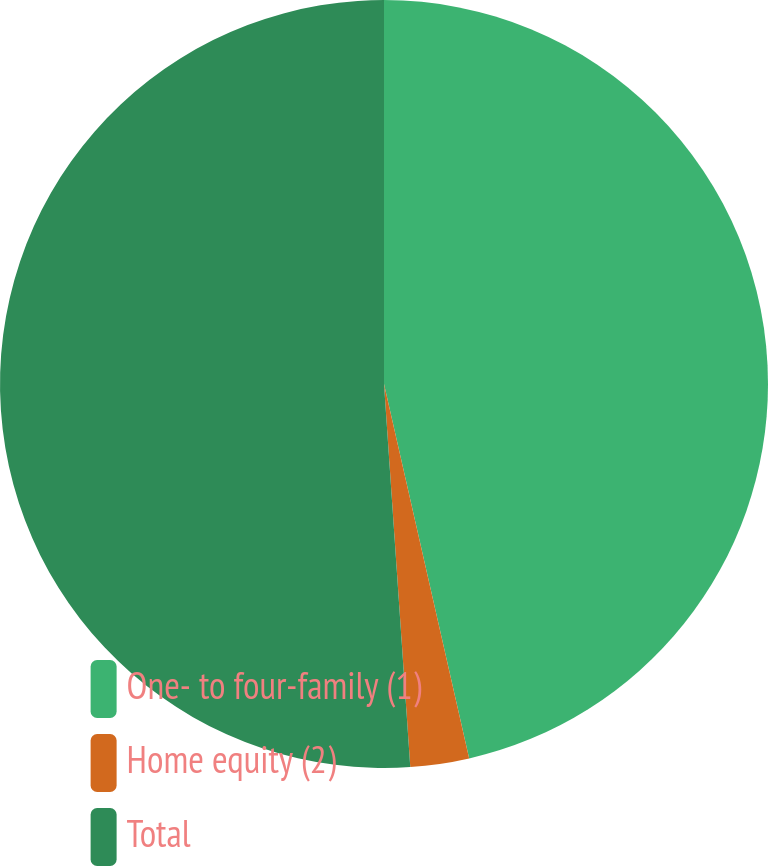Convert chart. <chart><loc_0><loc_0><loc_500><loc_500><pie_chart><fcel>One- to four-family (1)<fcel>Home equity (2)<fcel>Total<nl><fcel>46.44%<fcel>2.47%<fcel>51.09%<nl></chart> 